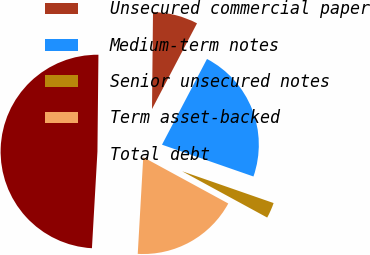Convert chart. <chart><loc_0><loc_0><loc_500><loc_500><pie_chart><fcel>Unsecured commercial paper<fcel>Medium-term notes<fcel>Senior unsecured notes<fcel>Term asset-backed<fcel>Total debt<nl><fcel>7.53%<fcel>22.63%<fcel>2.61%<fcel>17.97%<fcel>49.26%<nl></chart> 